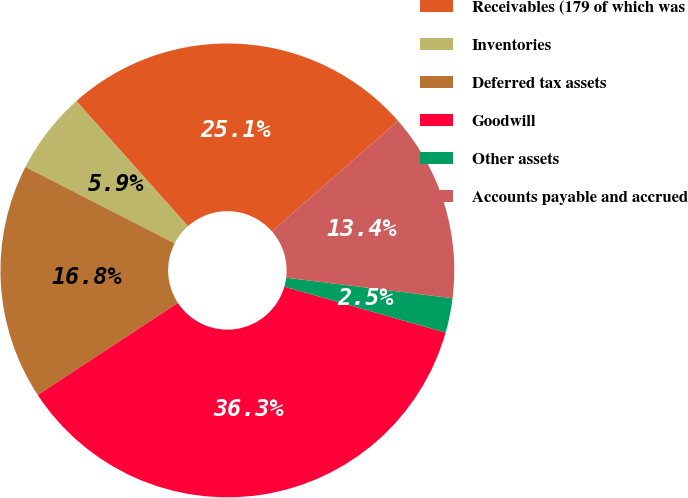<chart> <loc_0><loc_0><loc_500><loc_500><pie_chart><fcel>Receivables (179 of which was<fcel>Inventories<fcel>Deferred tax assets<fcel>Goodwill<fcel>Other assets<fcel>Accounts payable and accrued<nl><fcel>25.14%<fcel>5.87%<fcel>16.79%<fcel>36.33%<fcel>2.46%<fcel>13.41%<nl></chart> 